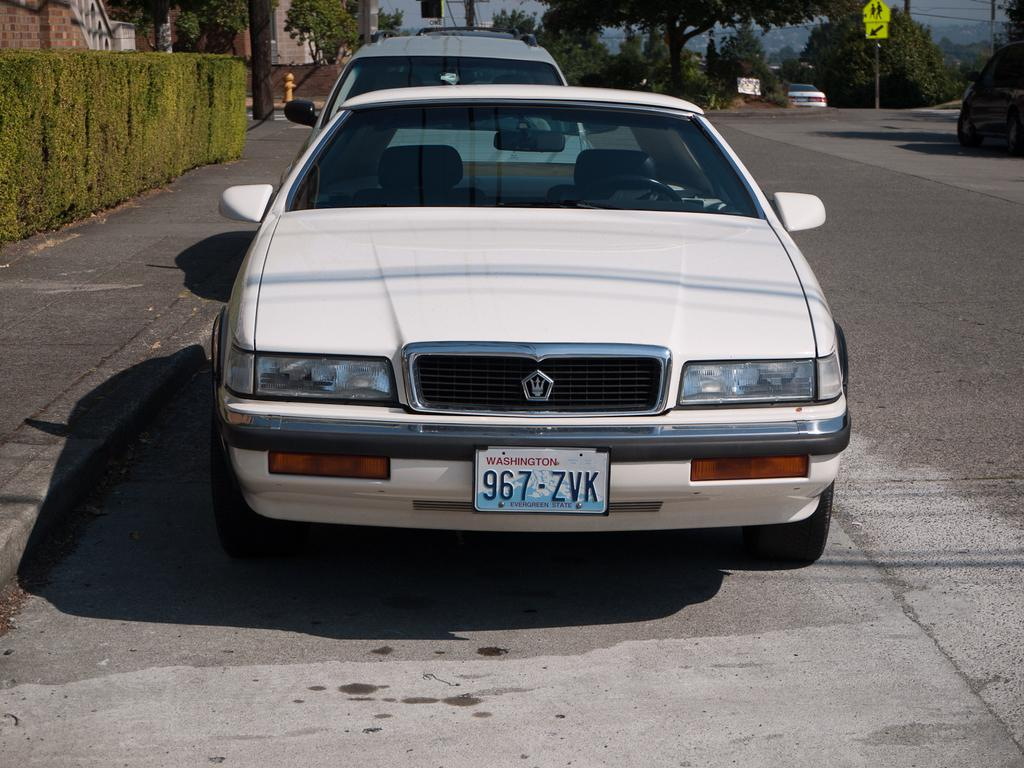What can be seen on the road in the image? There are cars on the road in the image. What type of vegetation is visible in the background of the image? There are plants and trees in the background of the image. What type of structures can be seen in the background of the image? There are buildings in the background of the image. What type of natural landform is visible in the background of the image? There are mountains in the background of the image. What part of the natural environment is visible in the background of the image? The sky is visible in the background of the image. How many chairs are visible in the image? There are no chairs present in the image. What type of cable can be seen connecting the mountains in the image? There is no cable connecting the mountains in the image; it is a natural landform. 